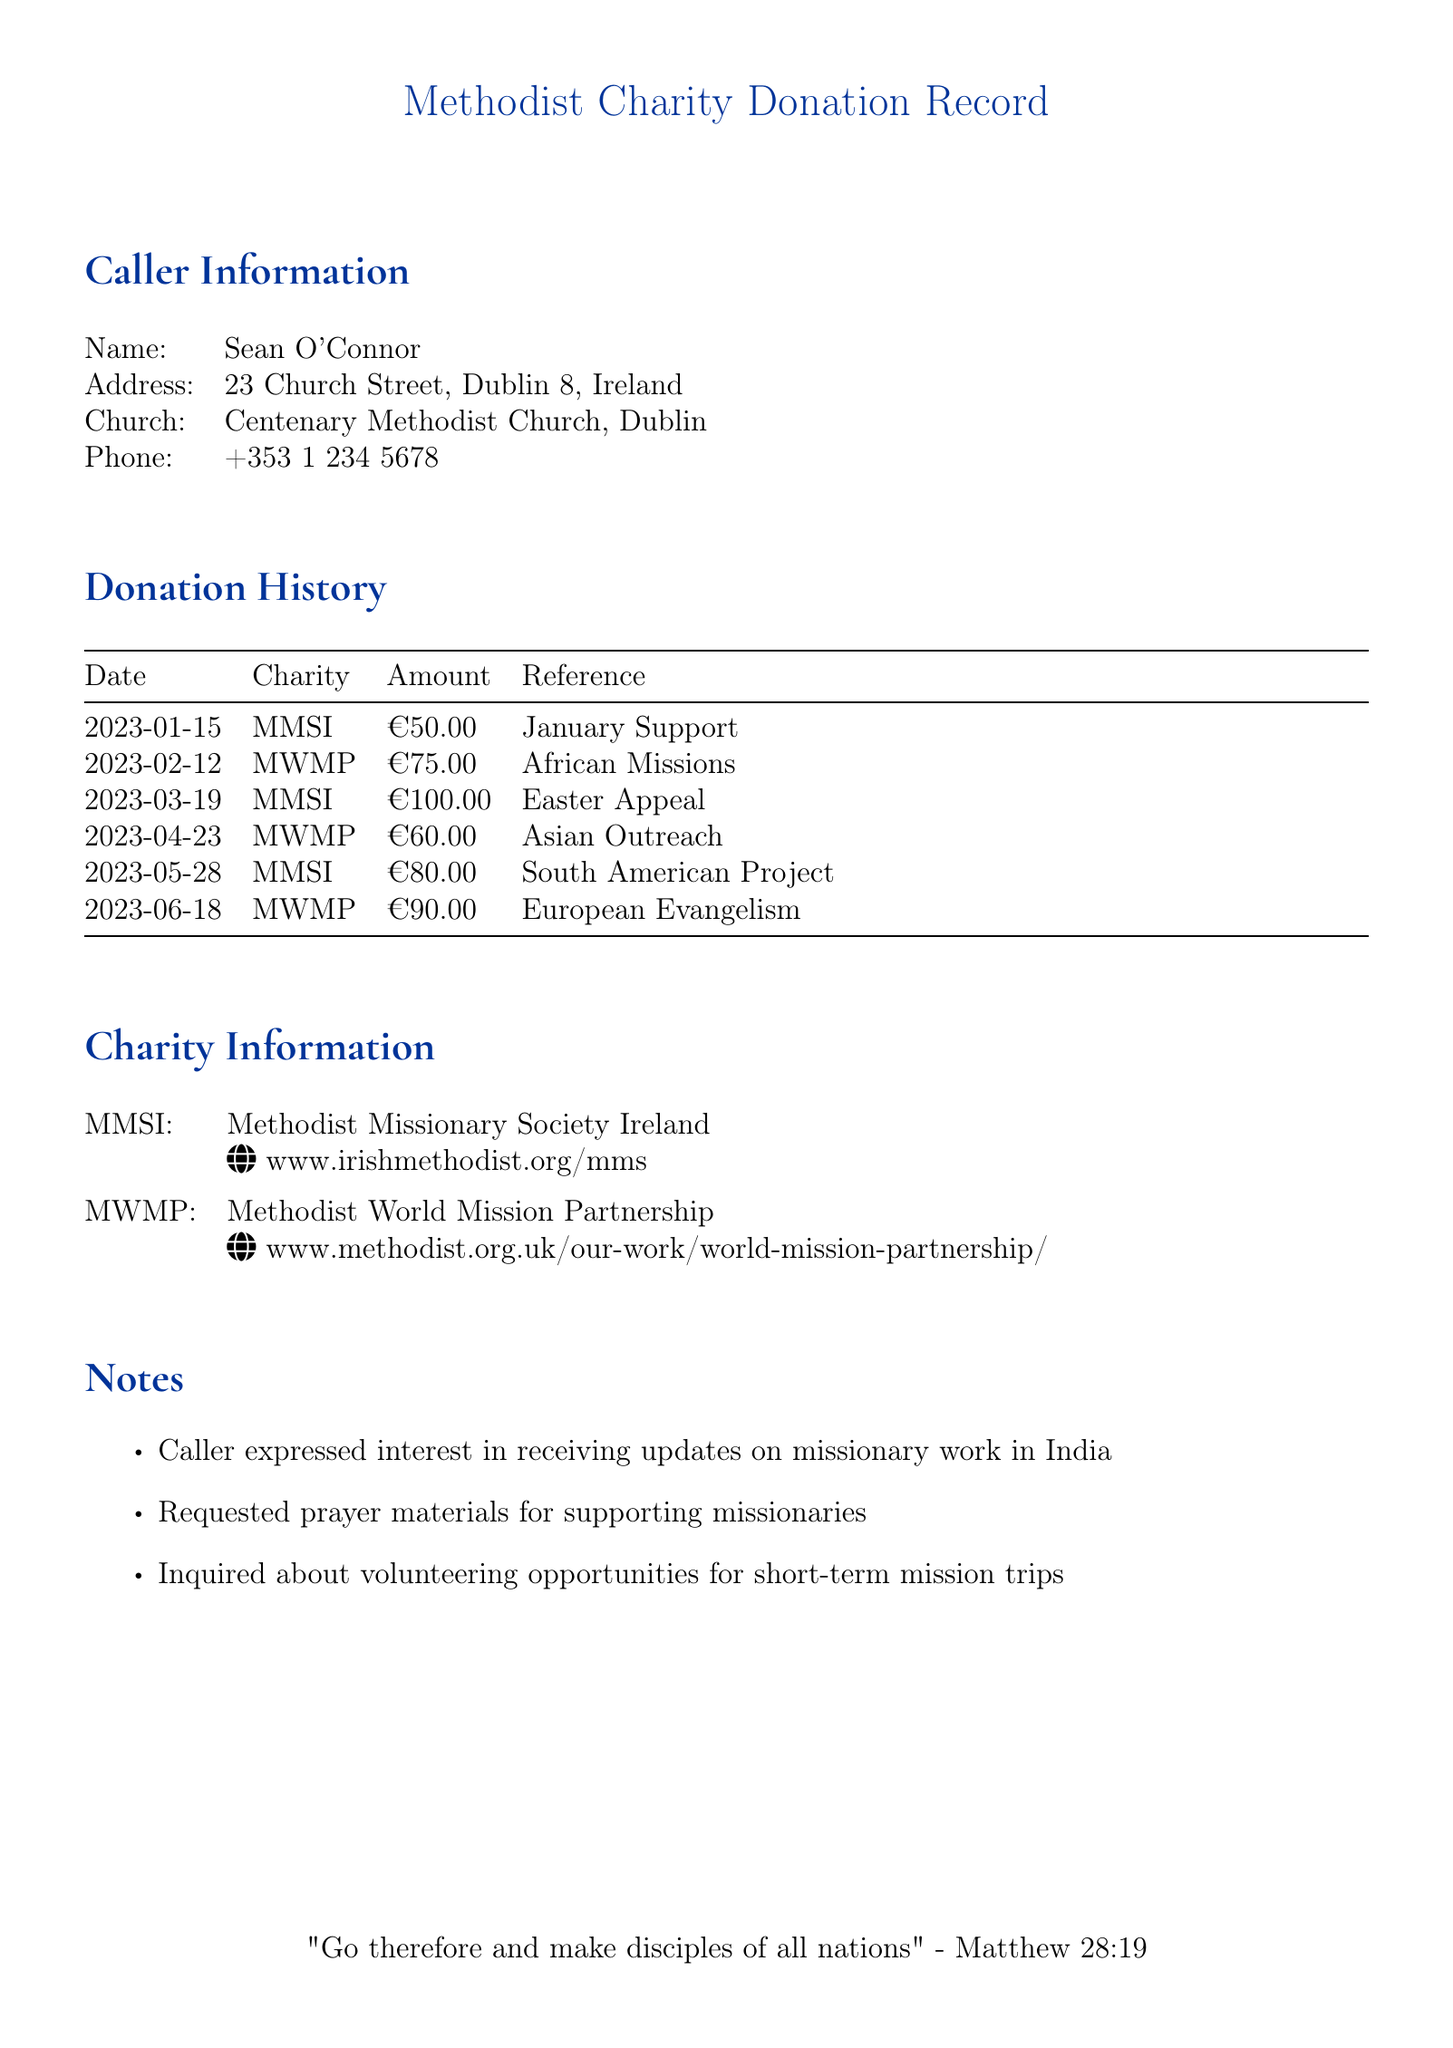what is the name of the caller? The caller's name is listed at the beginning of the document under Caller Information.
Answer: Sean O'Connor what is the address of the caller? The caller's address is provided in the Caller Information section.
Answer: 23 Church Street, Dublin 8, Ireland how much was donated on March 19, 2023? The amount donated on that date can be found in the Donation History table for that specific date.
Answer: €100.00 what charity is abbreviated as MWMP? The abbreviation for MWMP is explained in the Charity Information section.
Answer: Methodist World Mission Partnership how many donations were made in total? The total number of donations is counted from the entries in the Donation History section.
Answer: 6 what was the reference for the donation made on April 23? The reference for each donation is provided in the Donation History table.
Answer: Asian Outreach which specific charity received a donation of €80.00? The donation history lists which charity received each amount.
Answer: MMSI which scripture is quoted at the end of the document? The quoted scripture is provided at the bottom of the document.
Answer: Matthew 28:19 